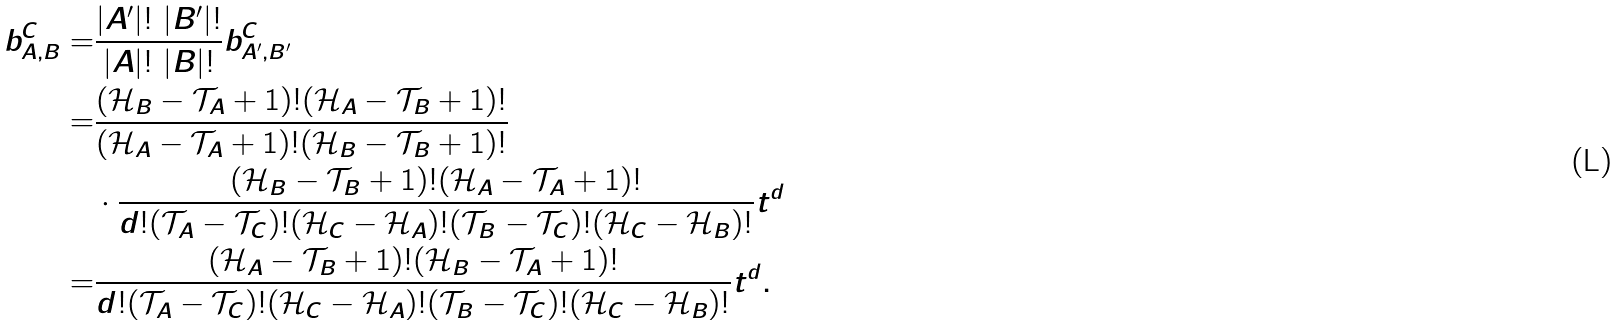Convert formula to latex. <formula><loc_0><loc_0><loc_500><loc_500>b _ { A , B } ^ { C } = & \frac { | A ^ { \prime } | ! \ | B ^ { \prime } | ! } { | A | ! \ | B | ! } b _ { A ^ { \prime } , B ^ { \prime } } ^ { C } \\ = & \frac { ( \mathcal { H } _ { B } - \mathcal { T } _ { A } + 1 ) ! ( \mathcal { H } _ { A } - \mathcal { T } _ { B } + 1 ) ! } { ( \mathcal { H } _ { A } - \mathcal { T } _ { A } + 1 ) ! ( \mathcal { H } _ { B } - \mathcal { T } _ { B } + 1 ) ! } \\ & \cdot \frac { ( \mathcal { H } _ { B } - \mathcal { T } _ { B } + 1 ) ! ( \mathcal { H } _ { A } - \mathcal { T } _ { A } + 1 ) ! } { d ! ( \mathcal { T } _ { A } - \mathcal { T } _ { C } ) ! ( \mathcal { H } _ { C } - \mathcal { H } _ { A } ) ! ( \mathcal { T } _ { B } - \mathcal { T } _ { C } ) ! ( \mathcal { H } _ { C } - \mathcal { H } _ { B } ) ! } t ^ { d } \\ = & \frac { ( \mathcal { H } _ { A } - \mathcal { T } _ { B } + 1 ) ! ( \mathcal { H } _ { B } - \mathcal { T } _ { A } + 1 ) ! } { d ! ( \mathcal { T } _ { A } - \mathcal { T } _ { C } ) ! ( \mathcal { H } _ { C } - \mathcal { H } _ { A } ) ! ( \mathcal { T } _ { B } - \mathcal { T } _ { C } ) ! ( \mathcal { H } _ { C } - \mathcal { H } _ { B } ) ! } t ^ { d } .</formula> 